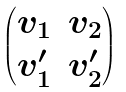Convert formula to latex. <formula><loc_0><loc_0><loc_500><loc_500>\begin{pmatrix} v _ { 1 } & v _ { 2 } \\ v _ { 1 } ^ { \prime } & v _ { 2 } ^ { \prime } \end{pmatrix}</formula> 